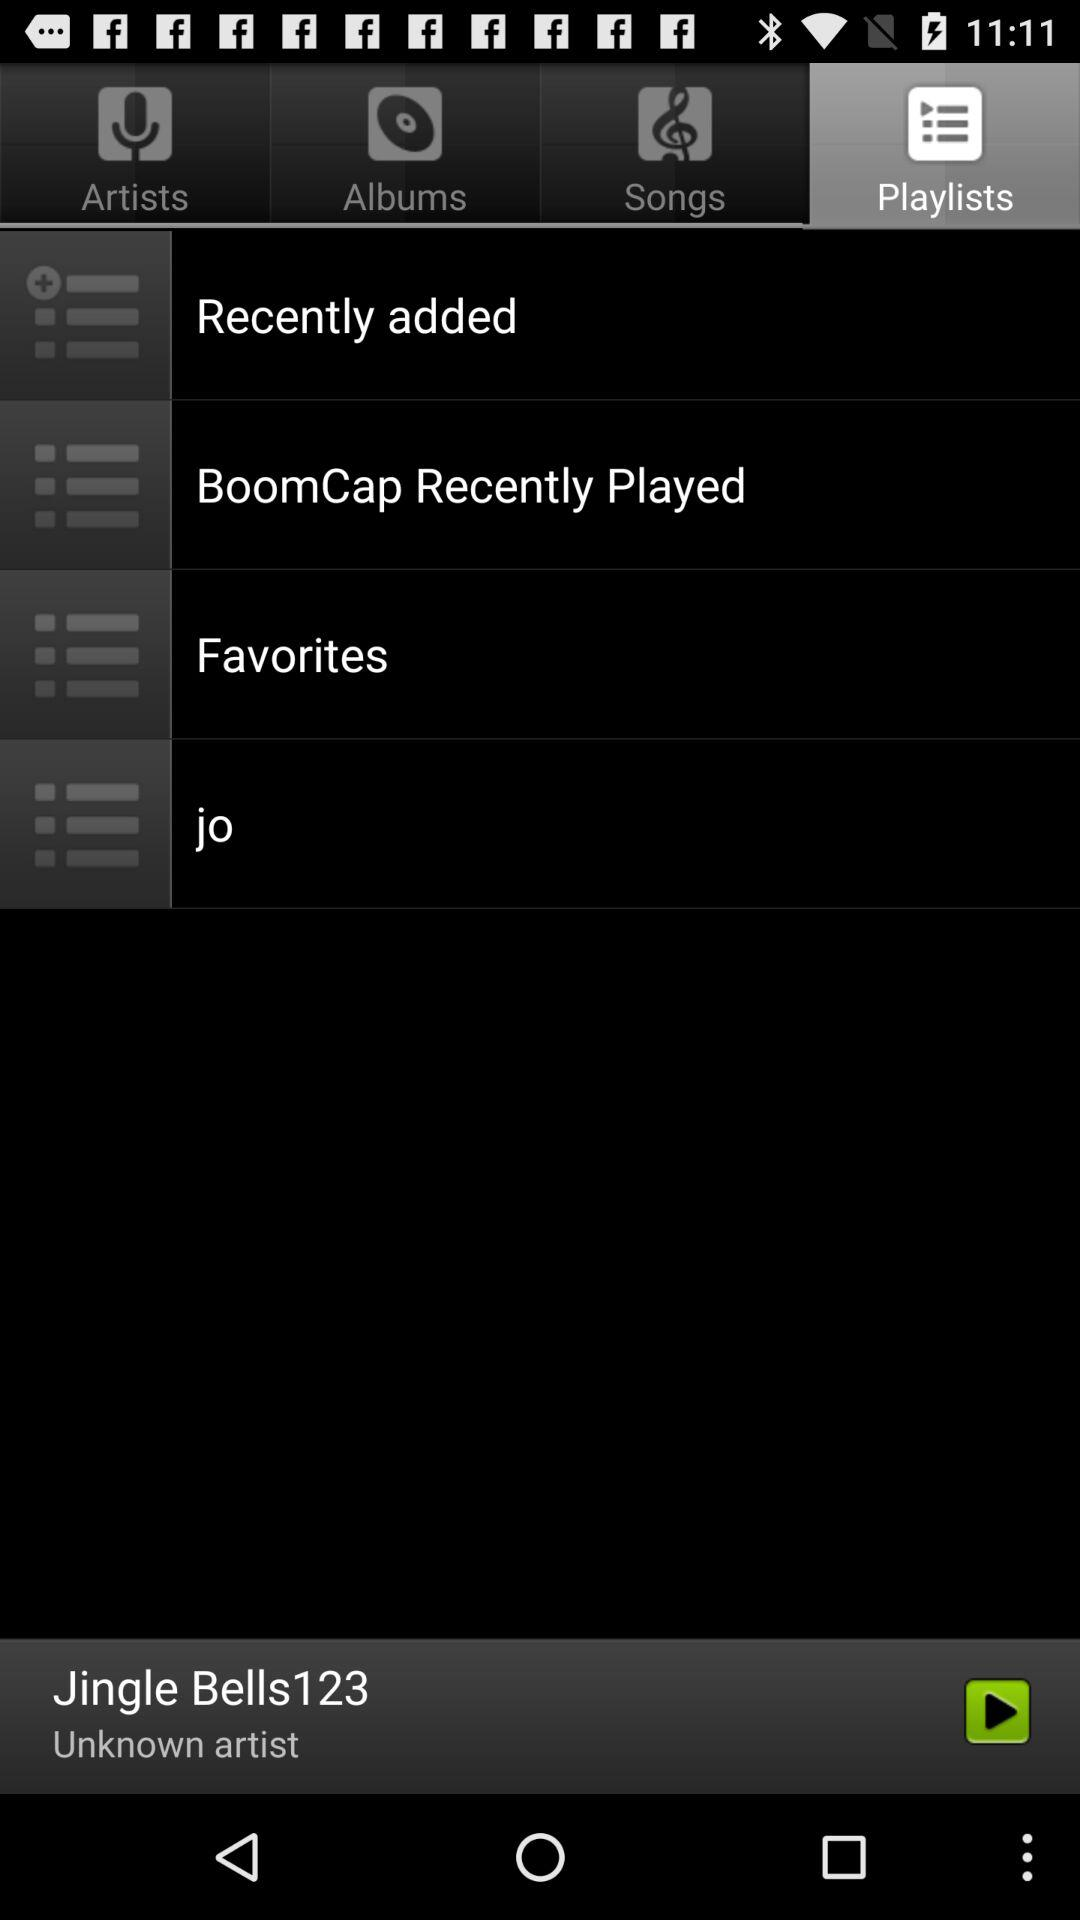Who is the artist of the audio "Jingle Bells123"? The artist of the audio is unknown. 